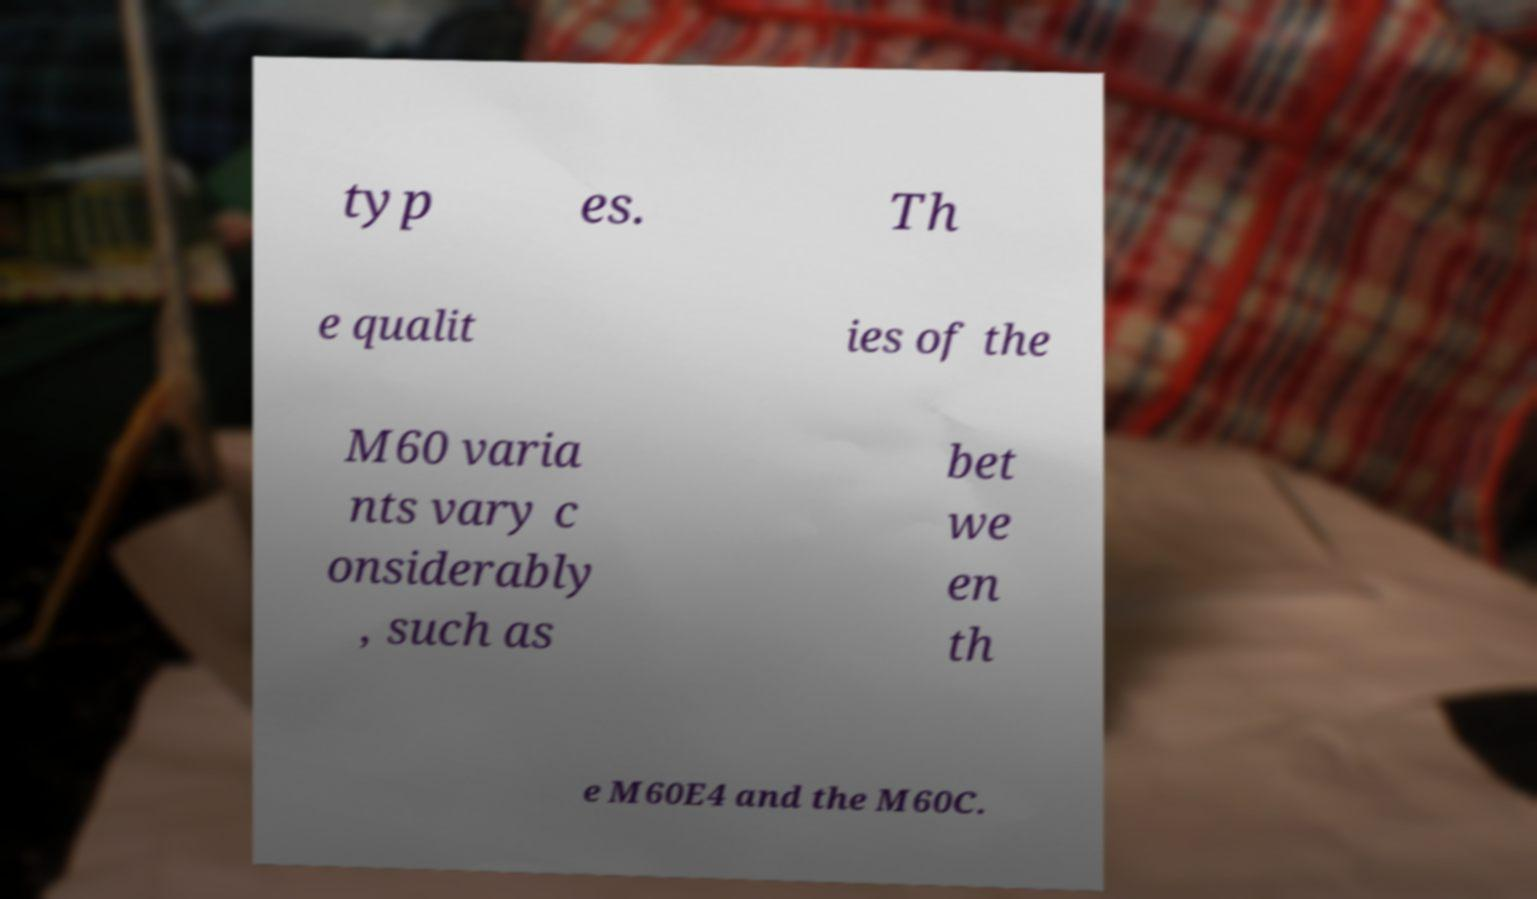What messages or text are displayed in this image? I need them in a readable, typed format. typ es. Th e qualit ies of the M60 varia nts vary c onsiderably , such as bet we en th e M60E4 and the M60C. 